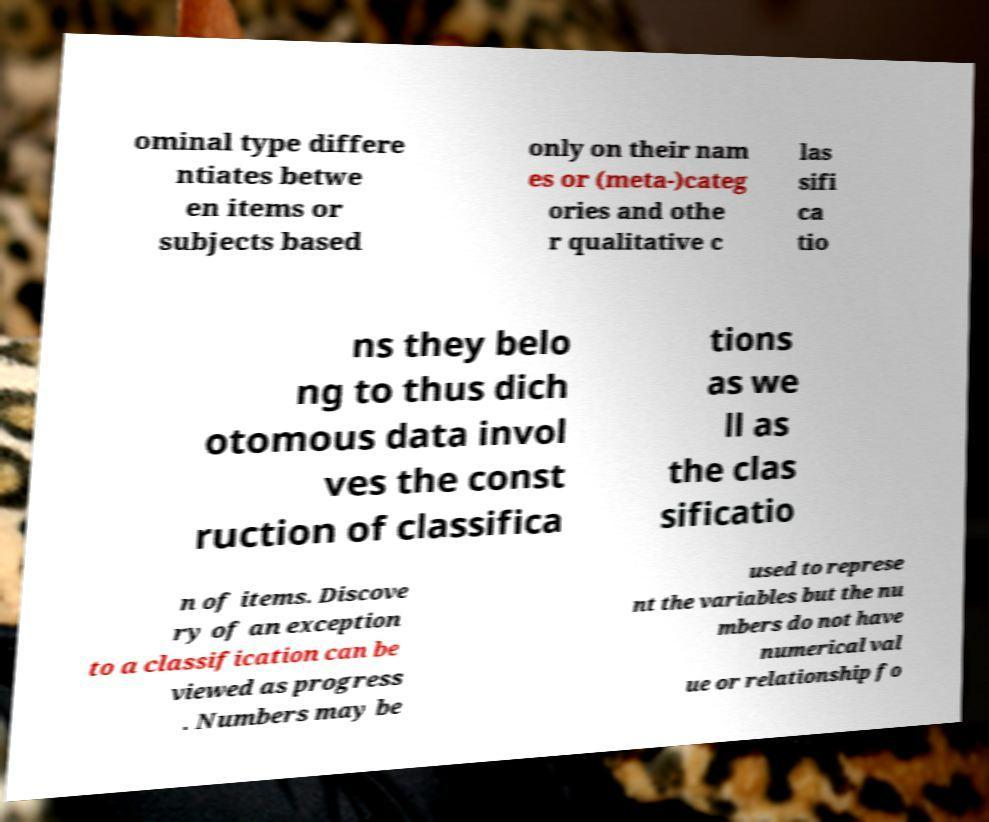Please identify and transcribe the text found in this image. ominal type differe ntiates betwe en items or subjects based only on their nam es or (meta-)categ ories and othe r qualitative c las sifi ca tio ns they belo ng to thus dich otomous data invol ves the const ruction of classifica tions as we ll as the clas sificatio n of items. Discove ry of an exception to a classification can be viewed as progress . Numbers may be used to represe nt the variables but the nu mbers do not have numerical val ue or relationship fo 